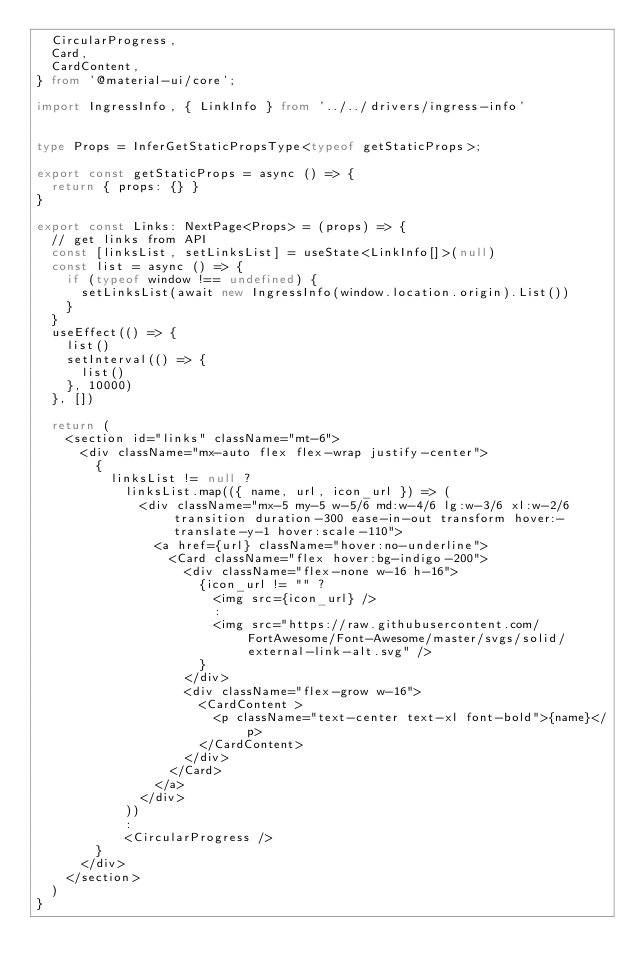<code> <loc_0><loc_0><loc_500><loc_500><_TypeScript_>  CircularProgress,
  Card,
  CardContent,
} from '@material-ui/core';

import IngressInfo, { LinkInfo } from '../../drivers/ingress-info'


type Props = InferGetStaticPropsType<typeof getStaticProps>;

export const getStaticProps = async () => {
  return { props: {} }
}

export const Links: NextPage<Props> = (props) => {
  // get links from API
  const [linksList, setLinksList] = useState<LinkInfo[]>(null)
  const list = async () => {
    if (typeof window !== undefined) {
      setLinksList(await new IngressInfo(window.location.origin).List())
    }
  }
  useEffect(() => {
    list()
    setInterval(() => {
      list()
    }, 10000)
  }, [])

  return (
    <section id="links" className="mt-6">
      <div className="mx-auto flex flex-wrap justify-center">
        {
          linksList != null ?
            linksList.map(({ name, url, icon_url }) => (
              <div className="mx-5 my-5 w-5/6 md:w-4/6 lg:w-3/6 xl:w-2/6 transition duration-300 ease-in-out transform hover:-translate-y-1 hover:scale-110">
                <a href={url} className="hover:no-underline">
                  <Card className="flex hover:bg-indigo-200">
                    <div className="flex-none w-16 h-16">
                      {icon_url != "" ?
                        <img src={icon_url} />
                        :
                        <img src="https://raw.githubusercontent.com/FortAwesome/Font-Awesome/master/svgs/solid/external-link-alt.svg" />
                      }
                    </div>
                    <div className="flex-grow w-16">
                      <CardContent >
                        <p className="text-center text-xl font-bold">{name}</p>
                      </CardContent>
                    </div>
                  </Card>
                </a>
              </div>
            ))
            :
            <CircularProgress />
        }
      </div>
    </section>
  )
}
</code> 